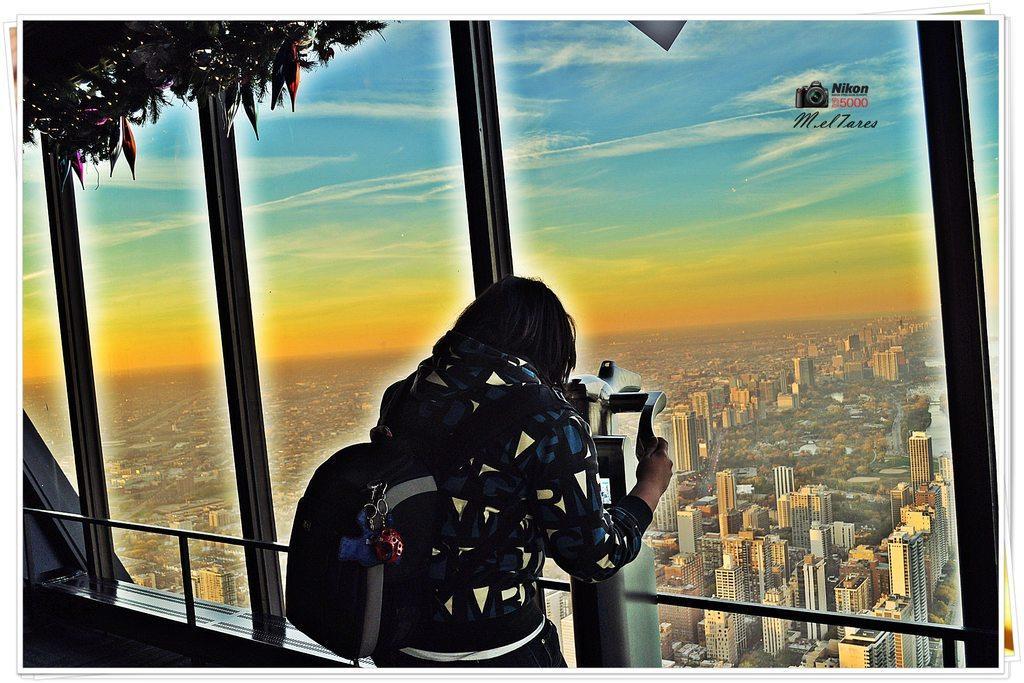Describe this image in one or two sentences. This picture seems to be an edited image. In the foreground we can see a person wearing backpack, standing and holding some object, we can see the metal rods and there are some objects hanging on the roof. In the background we can see the sky, buildings, trees and many other objects. In the top right corner we can see the watermark on the image. 